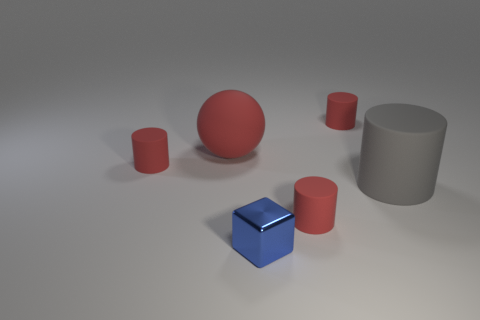How many red cylinders must be subtracted to get 1 red cylinders? 2 Subtract all brown blocks. How many red cylinders are left? 3 Subtract 1 cylinders. How many cylinders are left? 3 Add 2 large blue metallic cylinders. How many objects exist? 8 Subtract all purple cylinders. Subtract all brown spheres. How many cylinders are left? 4 Subtract all cylinders. How many objects are left? 2 Subtract all tiny cylinders. Subtract all metal things. How many objects are left? 2 Add 3 red rubber cylinders. How many red rubber cylinders are left? 6 Add 4 small red metallic cylinders. How many small red metallic cylinders exist? 4 Subtract 0 cyan spheres. How many objects are left? 6 